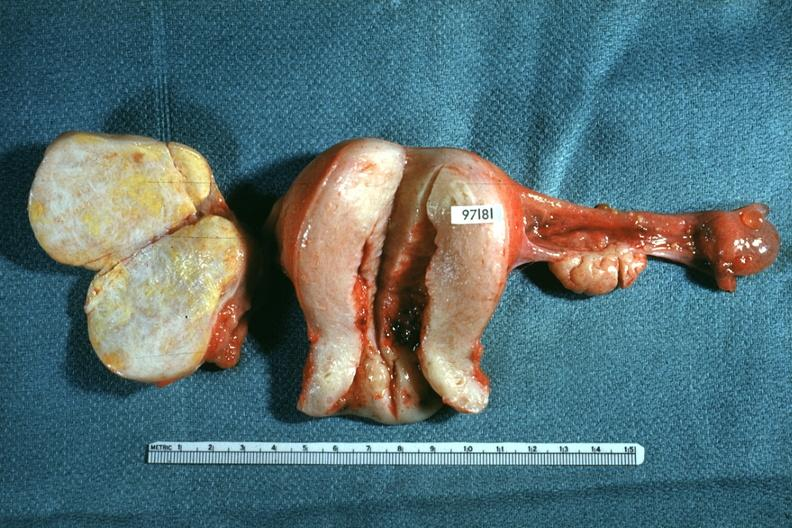what does this image show?
Answer the question using a single word or phrase. Ovaries and uterus with tumor mass 